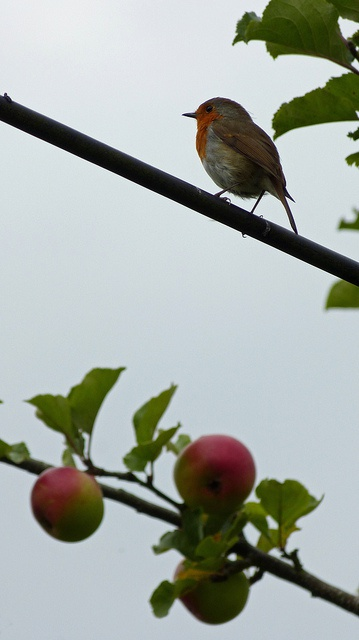Describe the objects in this image and their specific colors. I can see bird in white, black, maroon, gray, and darkgreen tones, apple in white, black, maroon, and brown tones, apple in white, black, maroon, olive, and brown tones, and apple in white, black, olive, darkgray, and gray tones in this image. 